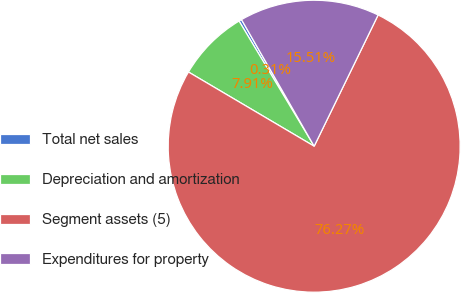<chart> <loc_0><loc_0><loc_500><loc_500><pie_chart><fcel>Total net sales<fcel>Depreciation and amortization<fcel>Segment assets (5)<fcel>Expenditures for property<nl><fcel>0.31%<fcel>7.91%<fcel>76.27%<fcel>15.51%<nl></chart> 